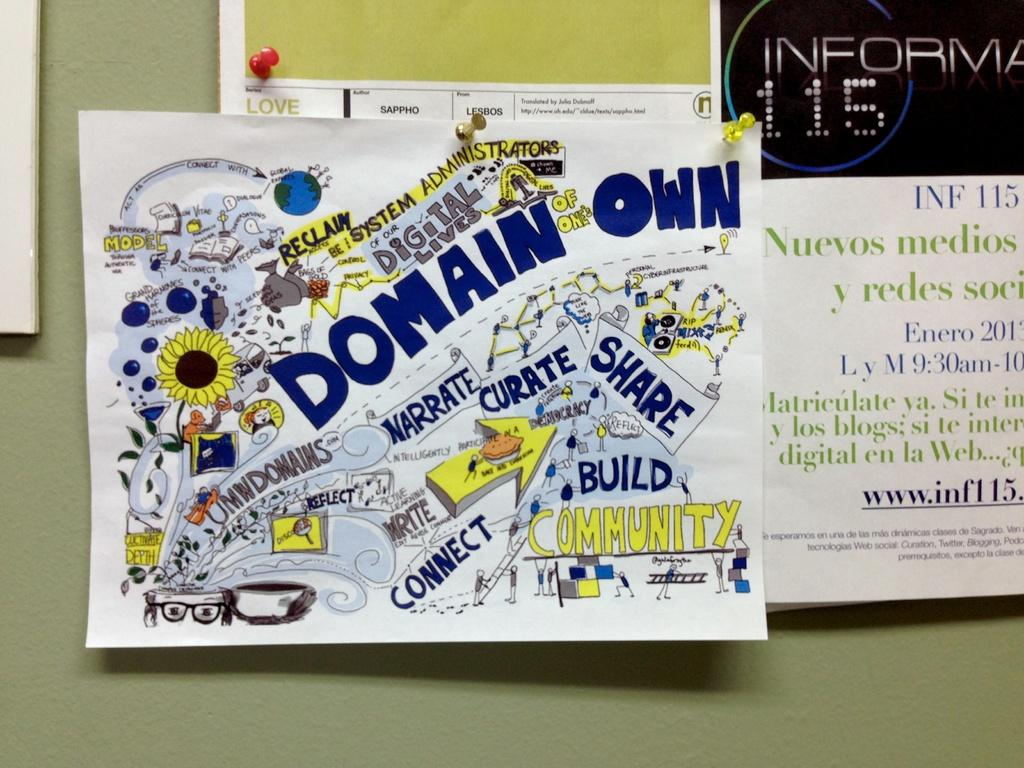<image>
Provide a brief description of the given image. Bulletin board fliers advertise the importance of community and digital lives 